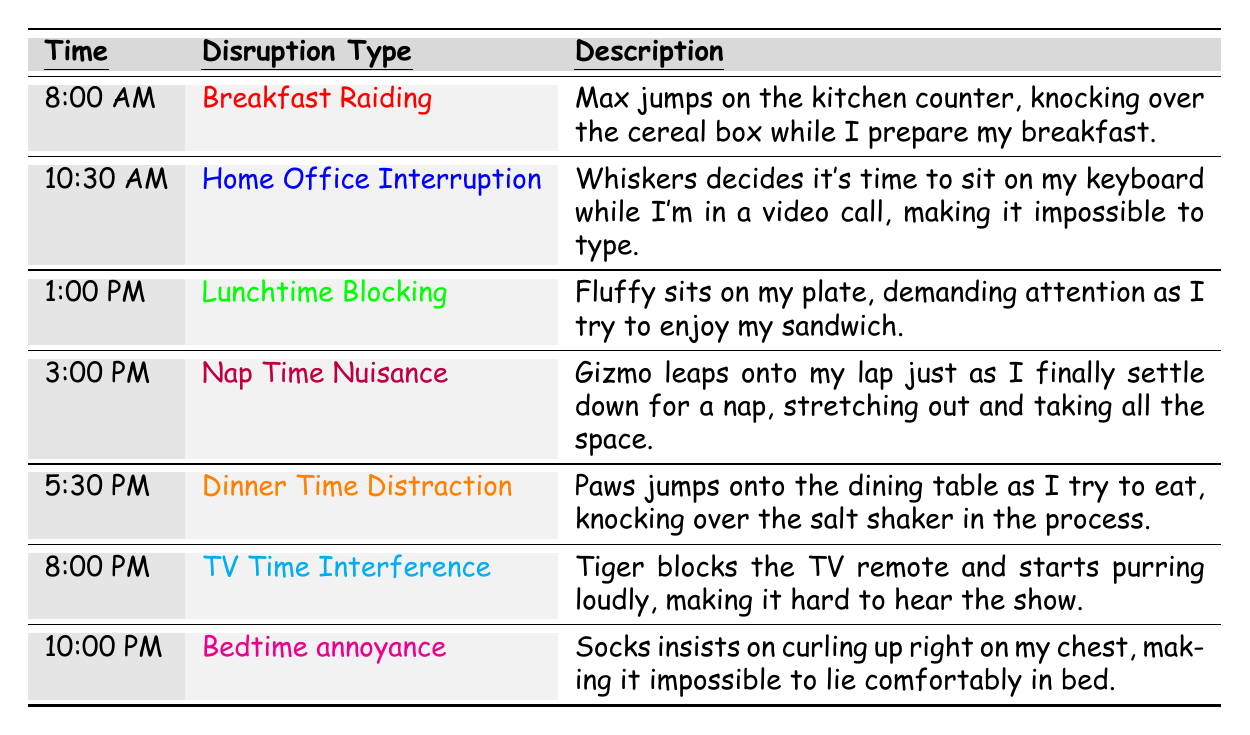What time does the Breakfast Raiding disruption occur? The table states that the Breakfast Raiding disruption happens at 8:00 AM.
Answer: 8:00 AM Who causes the Lunchtime Blocking disruption? According to the table, Fluffy is the cat that causes the Lunchtime Blocking disruption.
Answer: Fluffy How many disruptions occur before 3:00 PM? Looking at the times listed, there are three disruptions before 3:00 PM: Breakfast Raiding at 8:00 AM, Home Office Interruption at 10:30 AM, and Lunchtime Blocking at 1:00 PM.
Answer: 3 Which disruption has the description involving a video call? The Home Office Interruption disruption, which occurs at 10:30 AM, has the description related to a video call.
Answer: Home Office Interruption What is the total number of disruptions listed in the table? The table lists a total of seven disruptions, one for each time specified.
Answer: 7 Is there a disruption that involves a cat sitting on a plate? Yes, the Lunchtime Blocking disruption involves Fluffy sitting on a plate.
Answer: Yes At what time does the TV Time Interference disruption occur? The table indicates that the TV Time Interference disruption occurs at 8:00 PM.
Answer: 8:00 PM Which disruption involves a cat curling up on someone's chest? The Bedtime annoyance disruption involves Socks curling up on someone's chest.
Answer: Bedtime annoyance Are there more disruptions in the morning or the evening? There are four disruptions in the morning (up until 1:00 PM) and three in the evening (after 5:30 PM), so there are more in the morning.
Answer: Morning What is the description of the Nap Time Nuisance disruption? The Nap Time Nuisance disruption is described as Gizmo leaping onto the lap just as someone settles down for a nap.
Answer: Gizmo leaps onto lap during nap 